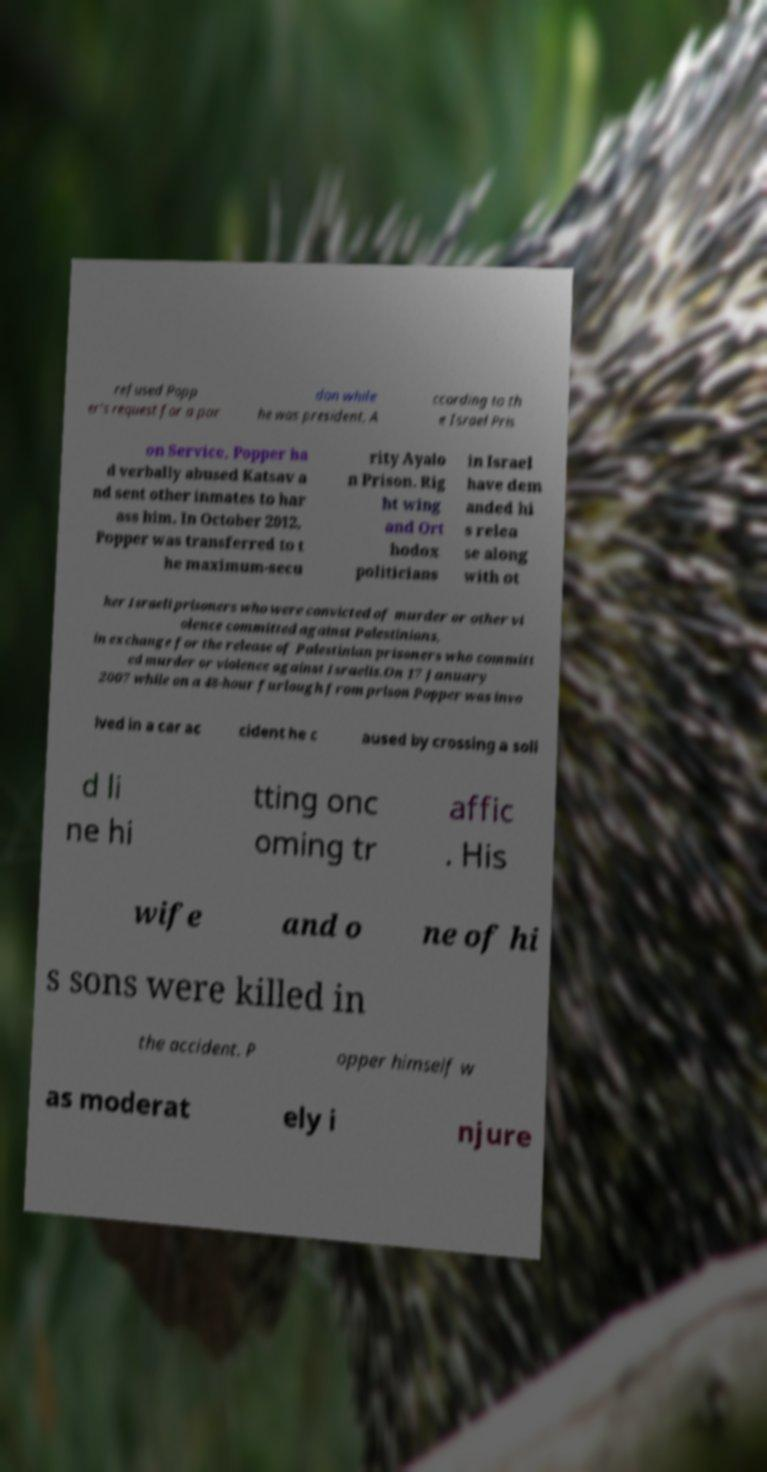Please read and relay the text visible in this image. What does it say? refused Popp er's request for a par don while he was president. A ccording to th e Israel Pris on Service, Popper ha d verbally abused Katsav a nd sent other inmates to har ass him. In October 2012, Popper was transferred to t he maximum-secu rity Ayalo n Prison. Rig ht wing and Ort hodox politicians in Israel have dem anded hi s relea se along with ot her Israeli prisoners who were convicted of murder or other vi olence committed against Palestinians, in exchange for the release of Palestinian prisoners who committ ed murder or violence against Israelis.On 17 January 2007 while on a 48-hour furlough from prison Popper was invo lved in a car ac cident he c aused by crossing a soli d li ne hi tting onc oming tr affic . His wife and o ne of hi s sons were killed in the accident. P opper himself w as moderat ely i njure 